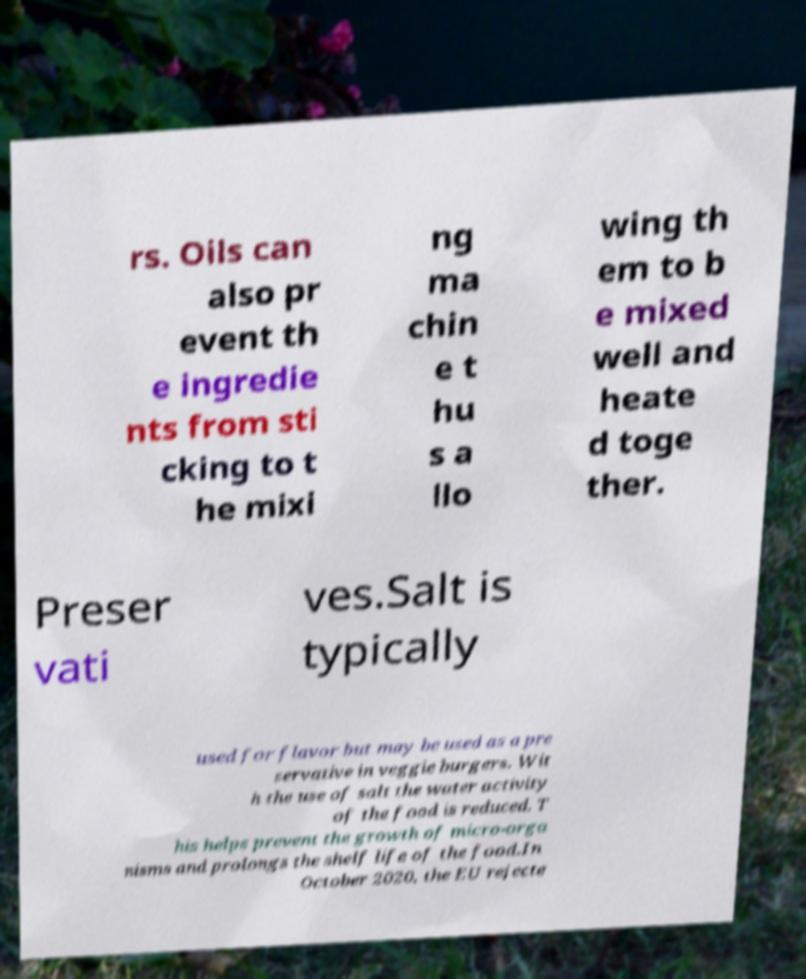I need the written content from this picture converted into text. Can you do that? rs. Oils can also pr event th e ingredie nts from sti cking to t he mixi ng ma chin e t hu s a llo wing th em to b e mixed well and heate d toge ther. Preser vati ves.Salt is typically used for flavor but may be used as a pre servative in veggie burgers. Wit h the use of salt the water activity of the food is reduced. T his helps prevent the growth of micro-orga nisms and prolongs the shelf life of the food.In October 2020, the EU rejecte 